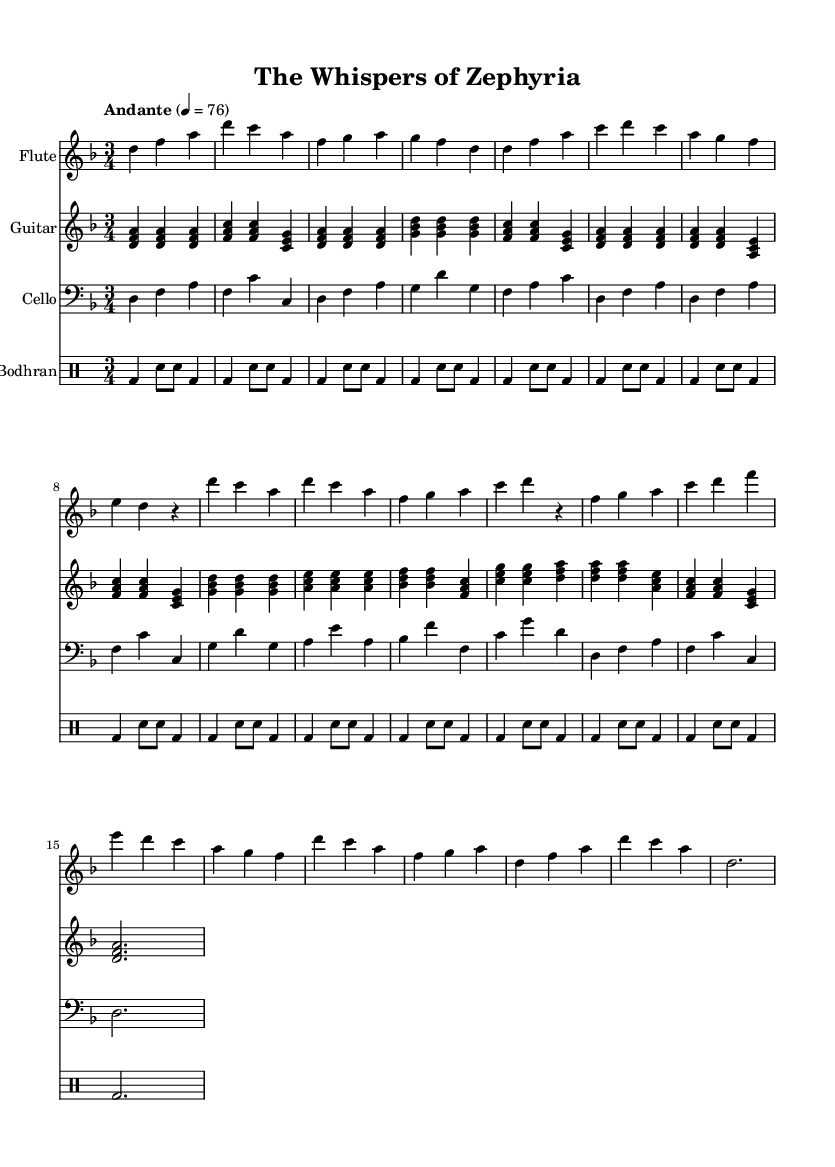What is the key signature of this music? The key signature is marked by the presence of two flats (B♭ and E♭) in the score, indicating that the piece is in the D minor key.
Answer: D minor What is the time signature of this music? The time signature is shown at the beginning of the score, indicated by the fraction 3/4, which signifies that there are three beats per measure and the quarter note gets one beat.
Answer: 3/4 What is the tempo marking of this piece? The tempo marking is located near the top of the score and indicates the speed of the music, which is set to "Andante," meaning a moderately slow tempo.
Answer: Andante How many measures are in the flute part? By counting the individual measures in the flute part of the score, I see that there are a total of 16 measures.
Answer: 16 In what style does this piece appear to be composed? The structure and instrumentation, along with the focus on storytelling elements commonly found in folk ballads, suggest that this piece embodies the style typical of traditional folk ballads.
Answer: Folk ballad What instruments are used in this score? The score specifies different staves, each indicating a specific instrument: flute, guitar, cello, and bodhran; thus these are the instruments included in this composition.
Answer: Flute, guitar, cello, bodhran How does the rhythm of the bodhran part contribute to the overall feel of the music? The bodhran part features a consistent pattern of beat and accents, which provides a rhythmic foundation and enhances the driving feel of the piece, supporting the melodic lines performed by the other instruments.
Answer: Rhythmic foundation 